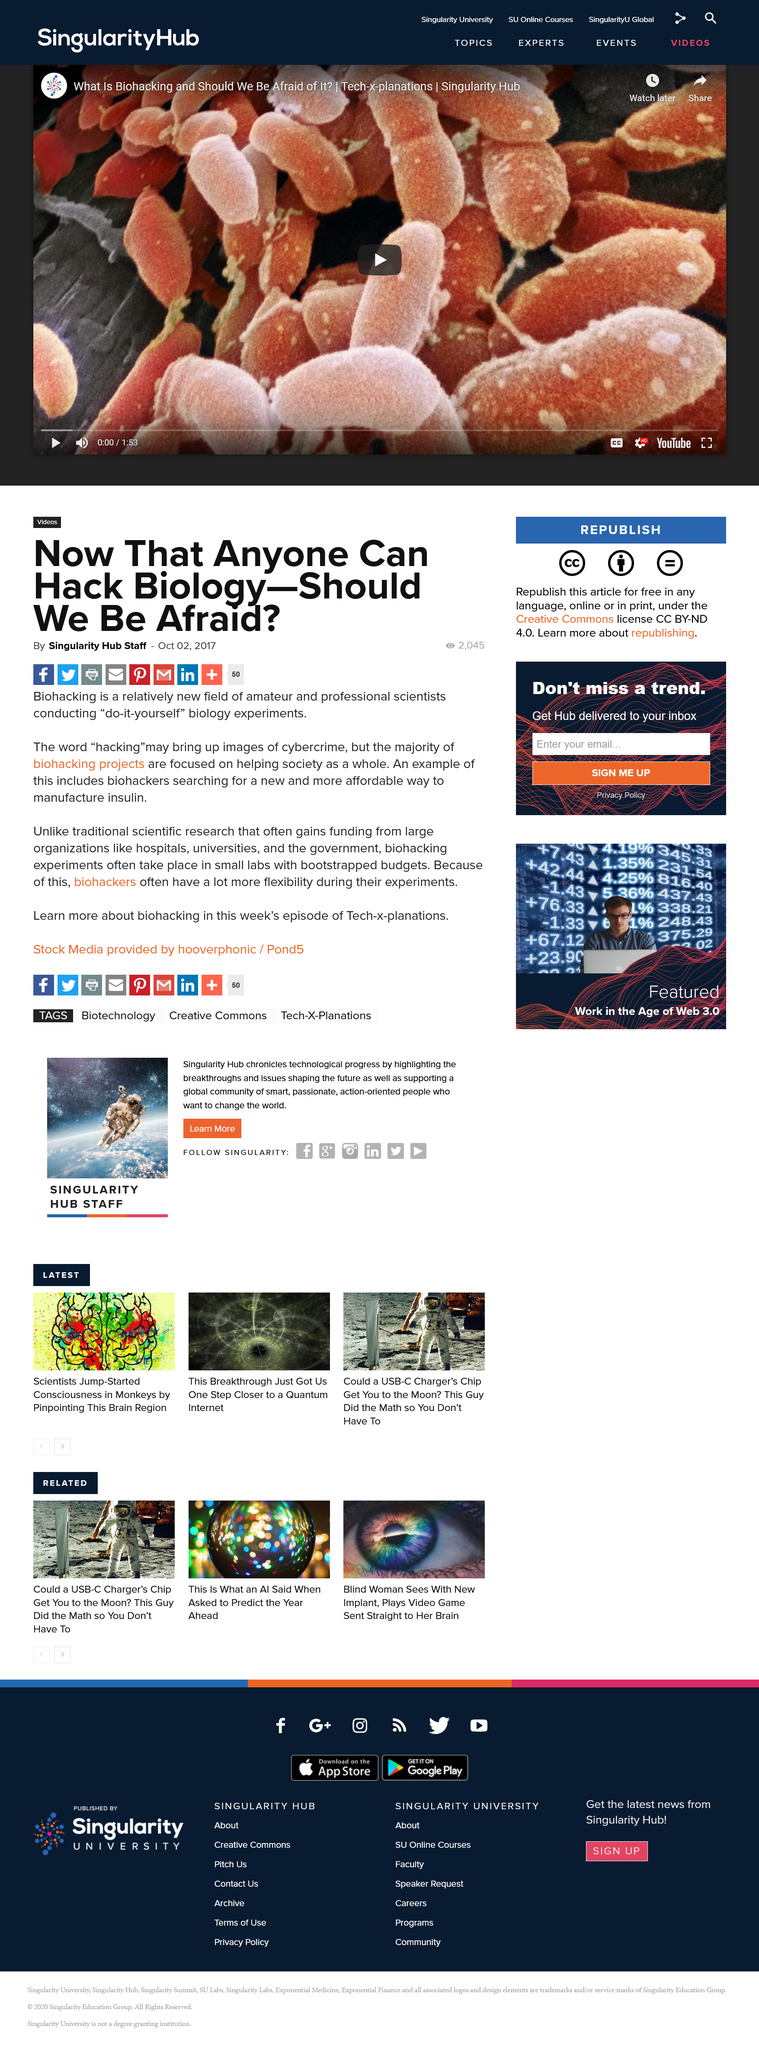Highlight a few significant elements in this photo. Biohacking is not limited to amateurs, as professional scientists are also conducting "do-it-yourself" biology experiments. Biohacking projects are generally not something to be feared, as the majority of them are focused on benefiting society. The term "biohacking" refers to the practice of conducting "do it yourself" biology experiments. 